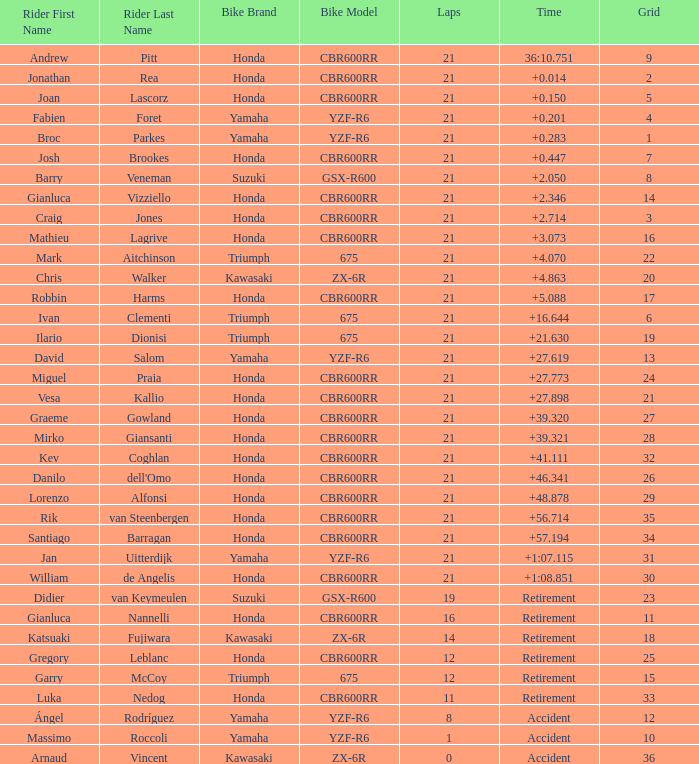What is the total of laps run by the driver with a grid under 17 and a time of +5.088? None. 